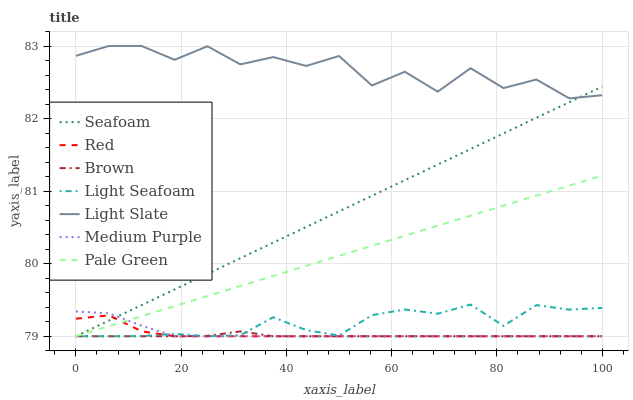Does Brown have the minimum area under the curve?
Answer yes or no. Yes. Does Seafoam have the minimum area under the curve?
Answer yes or no. No. Does Seafoam have the maximum area under the curve?
Answer yes or no. No. Is Seafoam the smoothest?
Answer yes or no. No. Is Seafoam the roughest?
Answer yes or no. No. Does Light Slate have the lowest value?
Answer yes or no. No. Does Seafoam have the highest value?
Answer yes or no. No. Is Medium Purple less than Light Slate?
Answer yes or no. Yes. Is Light Slate greater than Red?
Answer yes or no. Yes. Does Medium Purple intersect Light Slate?
Answer yes or no. No. 